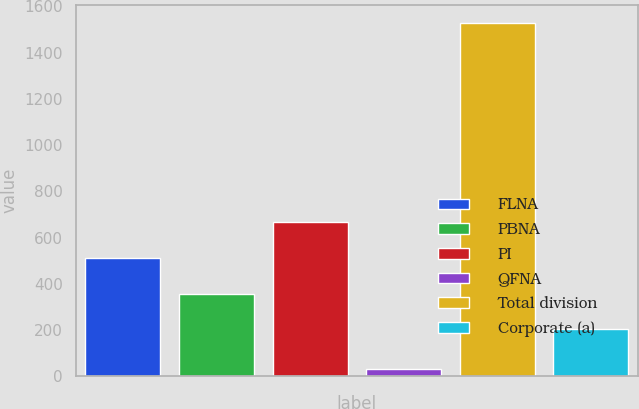Convert chart. <chart><loc_0><loc_0><loc_500><loc_500><bar_chart><fcel>FLNA<fcel>PBNA<fcel>PI<fcel>QFNA<fcel>Total division<fcel>Corporate (a)<nl><fcel>512<fcel>355.9<fcel>667<fcel>31<fcel>1530<fcel>206<nl></chart> 